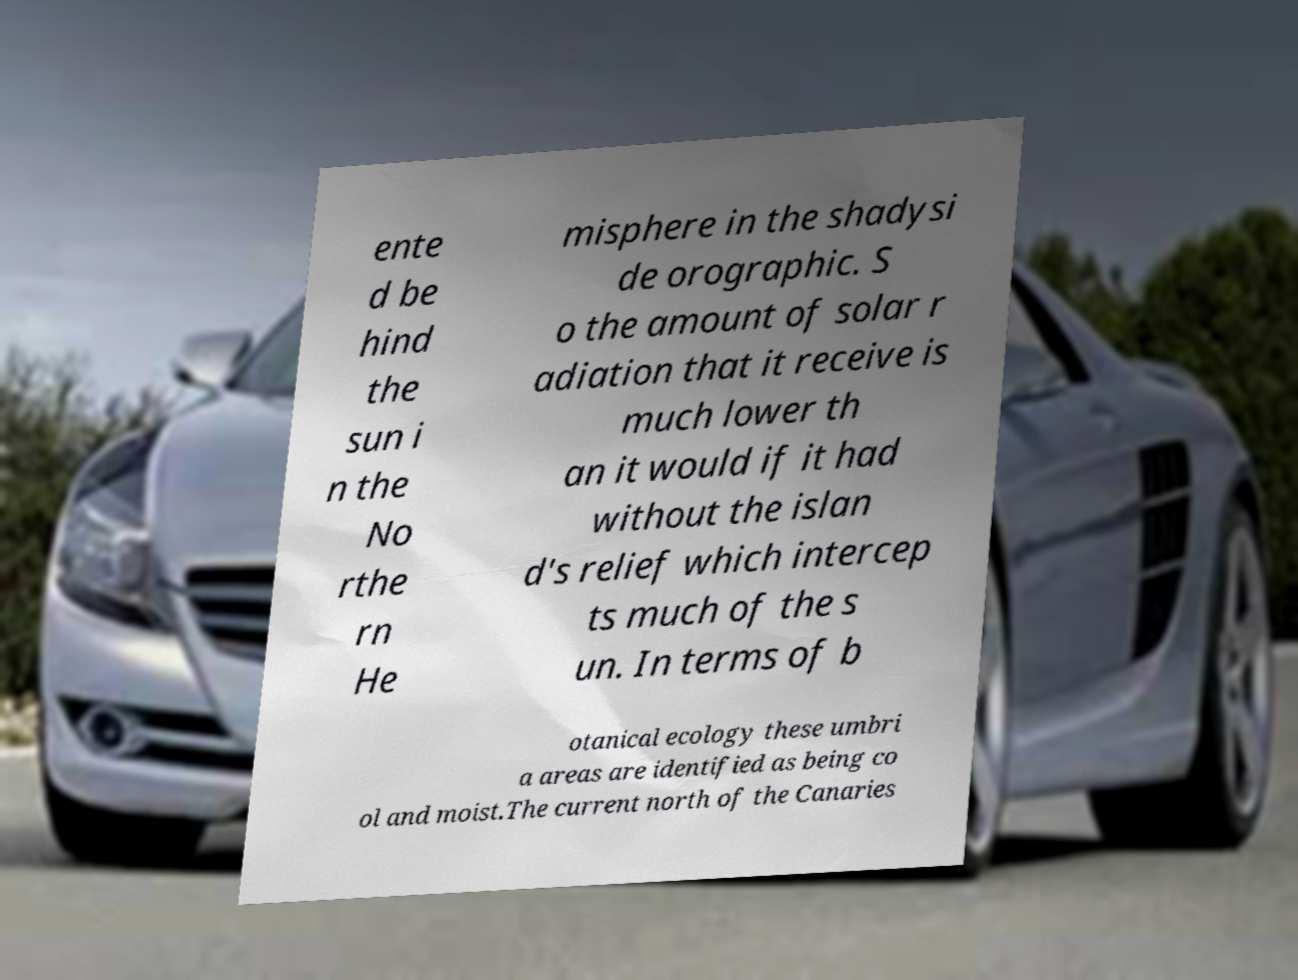Could you assist in decoding the text presented in this image and type it out clearly? ente d be hind the sun i n the No rthe rn He misphere in the shadysi de orographic. S o the amount of solar r adiation that it receive is much lower th an it would if it had without the islan d's relief which intercep ts much of the s un. In terms of b otanical ecology these umbri a areas are identified as being co ol and moist.The current north of the Canaries 